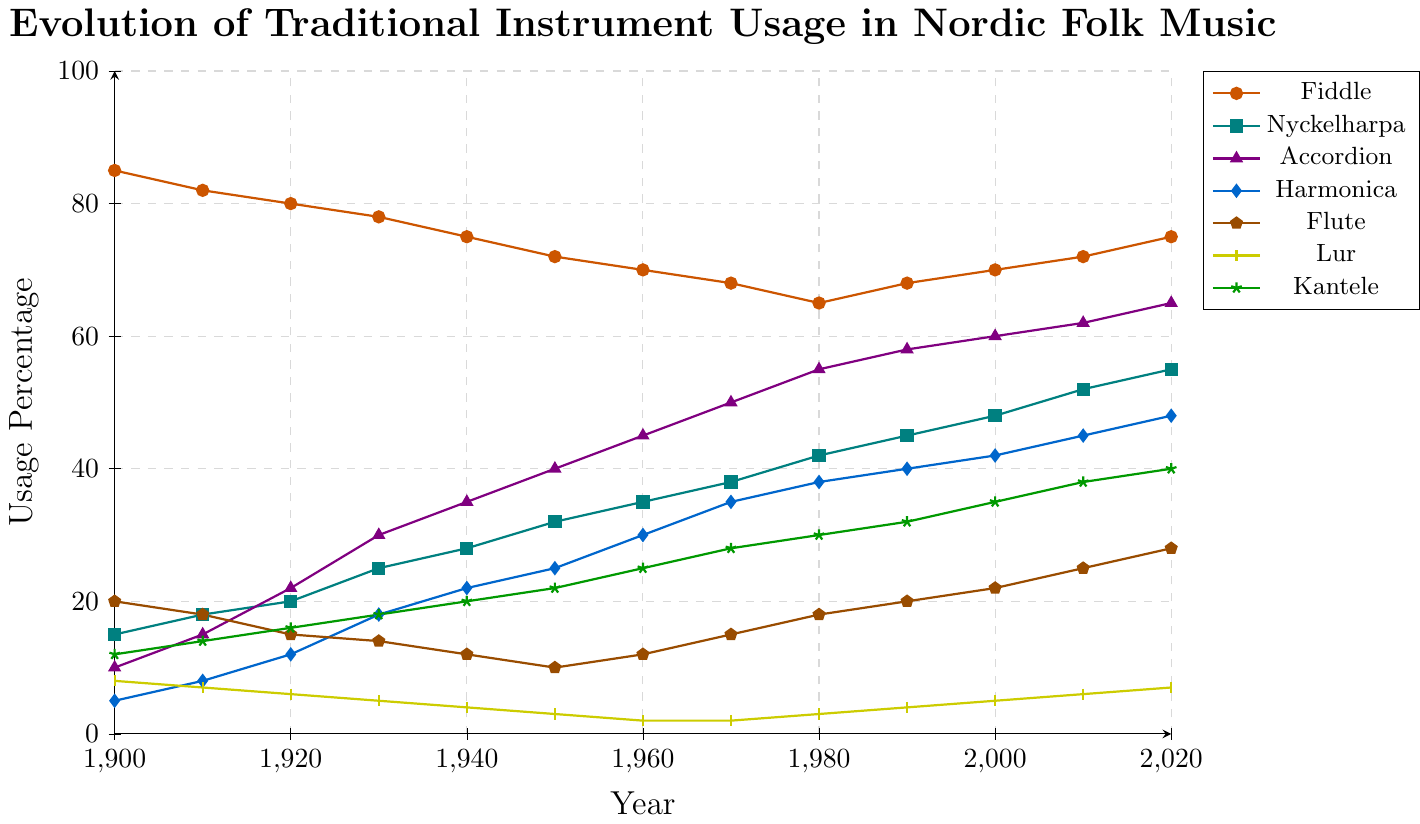What's the percentage change in Nyckelharpa usage from 1900 to 2020? To find the percentage change, subtract the earlier value (15 in 1900) from the later value (55 in 2020), then divide the result by the earlier value and multiply by 100. Percentage change = ((55 - 15) / 15) * 100 = 266.67%
Answer: 266.67% Which instrument saw the greatest increase in usage percentage over the time period? The dataset shows that we need to look at the increase in percentage for each instrument from 1900 to 2020. Fiddle increased by 75 - 85 = -10, Nyckelharpa by 55 - 15 = 40, Accordion by 65 - 10 = 55, Harmonica by 48 - 5 = 43, Flute by 28 - 20 = 8, Lur by 7 - 8 = -1, and Kantele by 40 - 12 = 28. Accordion saw the greatest increase.
Answer: Accordion By how much did the usage of the Flute drop from 1900 to 1950? The Flute usage in the year 1900 was 20, and in 1950 it was 10. The drop is calculated by subtracting 1950's value from 1900's value: 20 - 10 = 10.
Answer: 10 During which decade did the Harmonica experience the largest increase in usage? Looking at the data by decade: 1900-1910 (3%), 1910-1920 (4%), 1920-1930 (6%), 1930-1940 (4%), 1940-1950 (3%), 1950-1960 (5%), 1960-1970 (5%), 1970-1980 (3%), 1980-1990 (2%), 1990-2000 (2%), 2000-2010 (3%), 2010-2020 (3%). The largest increase (6%) occurred in the decade 1920-1930.
Answer: 1920-1930 What is the average usage percentage of the Kantele over the entire period? To find the average, sum the usage values for Kantele and divide by the number of years. Sum: 12+14+16+18+20+22+25+28+30+32+35+38+40 = 330. Number of years: 13. Average = 330 / 13 ≈ 25.38
Answer: 25.38 Which instrument had its lowest usage percentage in 1960, and what was the percentage? From the dataset, we can see that Lur had a usage percentage of 2 in 1960, which is the lowest for that year.
Answer: Lur, 2 How does the Lur's usage trend compare to the Fiddle's from 1900 to 2020? Both show a general trend of decline over the years. Lur usage falls from 8% to 7%, while Fiddle usage falls from 85% to 75%. However, Lur's usage slightly increased from 1980 onwards, whereas Fiddle shows a more significant decline and then a slight rise towards the end.
Answer: Both decreased but Fiddle had a more significant decline What was the combined usage percentage of Nyckelharpa and Kantele in 1940? To find the combined usage, add the usage percentages of Nyckelharpa (28%) and Kantele (20%) for the year 1940: 28 + 20 = 48%.
Answer: 48% Did the Accordion's usage percentage ever surpass 50%? In the figure, we can see that the Accordion's usage percentage surpasses 50% starting from 1970 (50%) and remains above 50% thereafter.
Answer: Yes, from 1970 onward Which instrument showed the most steady trend throughout the period? By observing the figure, the Nyckelharpa shows a relatively steady upward trend compared to other instruments with more fluctuations.
Answer: Nyckelharpa 